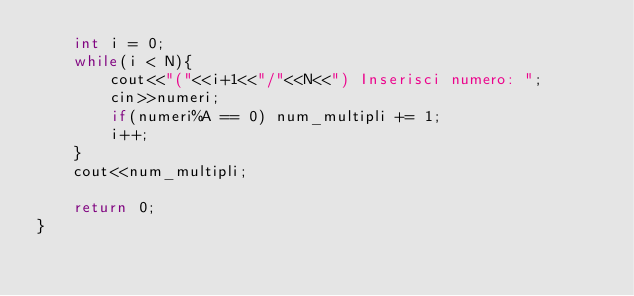<code> <loc_0><loc_0><loc_500><loc_500><_C++_>    int i = 0;
    while(i < N){
        cout<<"("<<i+1<<"/"<<N<<") Inserisci numero: ";
        cin>>numeri;
        if(numeri%A == 0) num_multipli += 1;
        i++;
    }
    cout<<num_multipli;

    return 0;
}
</code> 